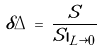Convert formula to latex. <formula><loc_0><loc_0><loc_500><loc_500>\delta \Delta \, = \, \frac { S } { S | _ { L \rightarrow 0 } }</formula> 